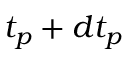Convert formula to latex. <formula><loc_0><loc_0><loc_500><loc_500>t _ { p } + d t _ { p }</formula> 